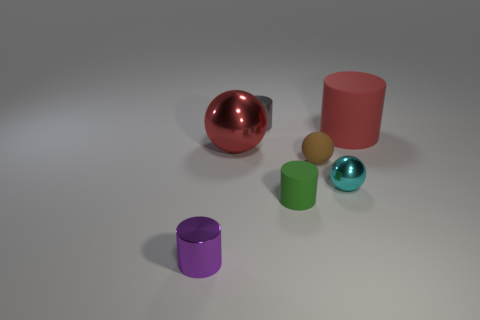Subtract all big cylinders. How many cylinders are left? 3 Add 1 tiny red shiny spheres. How many objects exist? 8 Subtract all red cylinders. How many cylinders are left? 3 Subtract all balls. How many objects are left? 4 Subtract 1 spheres. How many spheres are left? 2 Add 6 large rubber objects. How many large rubber objects are left? 7 Add 2 small matte cylinders. How many small matte cylinders exist? 3 Subtract 0 gray balls. How many objects are left? 7 Subtract all yellow balls. Subtract all purple cylinders. How many balls are left? 3 Subtract all big blue metallic cylinders. Subtract all small metallic balls. How many objects are left? 6 